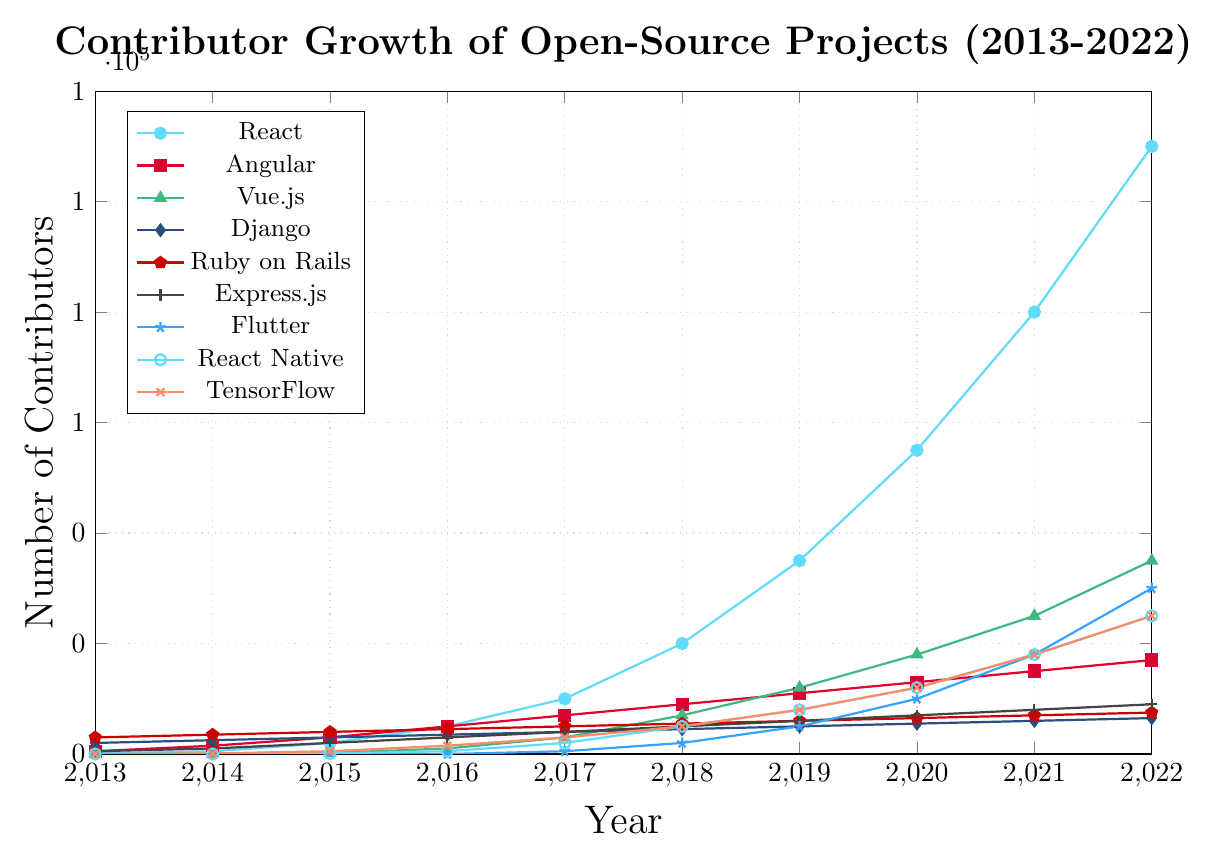Which project had the highest number of contributors in 2013? By reviewing the figure, we find that Ruby on Rails had the highest number of contributors in 2013, indicated by the height of its mark which is highest among all colors in that year.
Answer: Ruby on Rails What is the difference in the number of contributors between React and Angular in 2022? To find the difference, look at the marks for 2022 for React (110,000) and Angular (17,000). The difference is calculated as 110,000 - 17,000 = 93,000.
Answer: 93,000 Which project experienced the most significant growth in contributors from 2014 to 2018? Examine each project’s contributors in 2014 and 2018. React grew from 500 to 20,000, Angular from 1,500 to 9,000, Vue.js from 50 to 7,000, and so on. React's increase (19,500) is the largest.
Answer: React Which framework had more contributors in 2020, Django or Vue.js? Compare the marks for Django and Vue.js in 2020. Django had 5,500 contributors, while Vue.js had 18,000 contributors. Thus, Vue.js had more contributors.
Answer: Vue.js What is the average number of contributors for TensorFlow from 2018 to 2022? Add the data points for TensorFlow from 2018 to 2022 (5,000 + 8,000 + 12,000 + 18,000 + 25,000) and divide by the number of points, which is 5. So, the average is (5,000 + 8,000 + 12,000 + 18,000 + 25,000) / 5 = 13,600.
Answer: 13,600 How many more contributors did React Native have in 2021 compared to 2015? Look at React Native's marks for 2021 (18,000) and 2015 (100). The difference is 18,000 - 100 = 17,900.
Answer: 17,900 Which project had the least contributors in 2022 and how many did it have? By checking the marks for all projects in 2022, Django had the least contributors with 6,500.
Answer: Django with 6,500 What is the combined total number of contributors for Express.js and Flutter in 2022? Adding the contributors for Express.js (9,000) and Flutter (30,000) in 2022 gives 9,000 + 30,000 = 39,000.
Answer: 39,000 Which backend framework saw the most steady growth in the number of contributors across the decade? Assessing the backend frameworks (Django, Ruby on Rails, Express.js), we find Django increased steadily from 2,000 to 6,500 consistently without any sudden spikes.
Answer: Django 